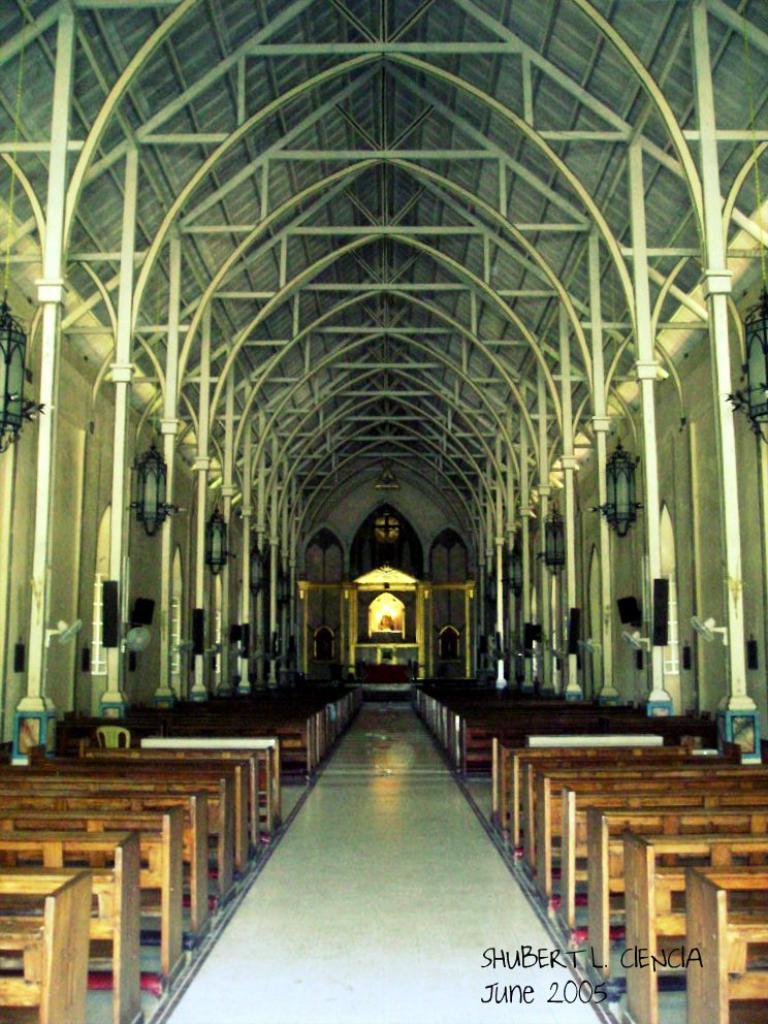What month was the photo taken?
Your answer should be very brief. June. What year was the photo taken?
Your answer should be very brief. 2005. 